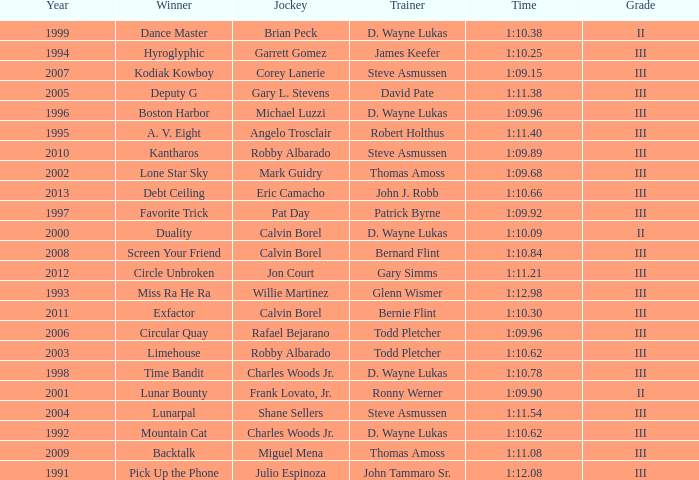Who won under Gary Simms? Circle Unbroken. 